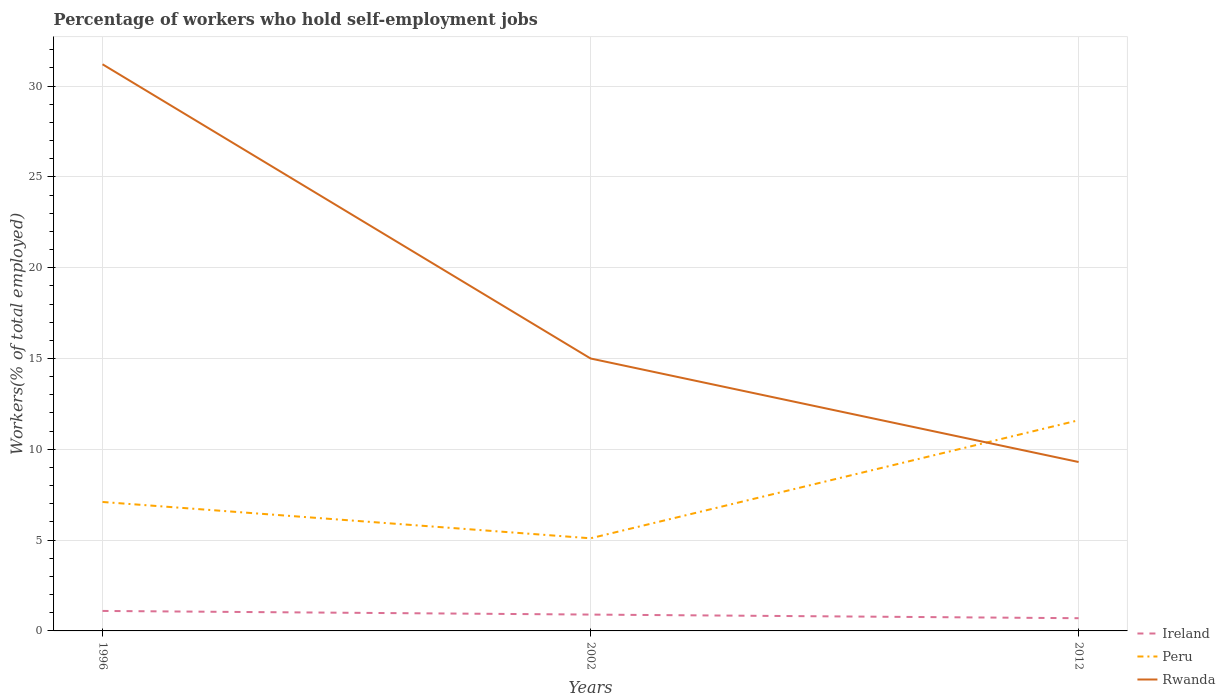Does the line corresponding to Ireland intersect with the line corresponding to Peru?
Give a very brief answer. No. Is the number of lines equal to the number of legend labels?
Keep it short and to the point. Yes. Across all years, what is the maximum percentage of self-employed workers in Rwanda?
Your answer should be very brief. 9.3. In which year was the percentage of self-employed workers in Ireland maximum?
Your answer should be very brief. 2012. What is the total percentage of self-employed workers in Ireland in the graph?
Your response must be concise. 0.4. What is the difference between the highest and the second highest percentage of self-employed workers in Peru?
Provide a short and direct response. 6.5. What is the difference between the highest and the lowest percentage of self-employed workers in Peru?
Keep it short and to the point. 1. Is the percentage of self-employed workers in Peru strictly greater than the percentage of self-employed workers in Rwanda over the years?
Ensure brevity in your answer.  No. How many lines are there?
Provide a short and direct response. 3. What is the difference between two consecutive major ticks on the Y-axis?
Offer a terse response. 5. Are the values on the major ticks of Y-axis written in scientific E-notation?
Your answer should be compact. No. Does the graph contain any zero values?
Ensure brevity in your answer.  No. Where does the legend appear in the graph?
Your answer should be very brief. Bottom right. How many legend labels are there?
Offer a very short reply. 3. What is the title of the graph?
Make the answer very short. Percentage of workers who hold self-employment jobs. What is the label or title of the X-axis?
Ensure brevity in your answer.  Years. What is the label or title of the Y-axis?
Provide a short and direct response. Workers(% of total employed). What is the Workers(% of total employed) in Ireland in 1996?
Provide a succinct answer. 1.1. What is the Workers(% of total employed) in Peru in 1996?
Offer a terse response. 7.1. What is the Workers(% of total employed) of Rwanda in 1996?
Provide a short and direct response. 31.2. What is the Workers(% of total employed) in Ireland in 2002?
Your answer should be very brief. 0.9. What is the Workers(% of total employed) of Peru in 2002?
Ensure brevity in your answer.  5.1. What is the Workers(% of total employed) in Rwanda in 2002?
Make the answer very short. 15. What is the Workers(% of total employed) in Ireland in 2012?
Your answer should be compact. 0.7. What is the Workers(% of total employed) of Peru in 2012?
Your response must be concise. 11.6. What is the Workers(% of total employed) of Rwanda in 2012?
Your response must be concise. 9.3. Across all years, what is the maximum Workers(% of total employed) in Ireland?
Keep it short and to the point. 1.1. Across all years, what is the maximum Workers(% of total employed) of Peru?
Provide a short and direct response. 11.6. Across all years, what is the maximum Workers(% of total employed) of Rwanda?
Ensure brevity in your answer.  31.2. Across all years, what is the minimum Workers(% of total employed) of Ireland?
Provide a short and direct response. 0.7. Across all years, what is the minimum Workers(% of total employed) of Peru?
Keep it short and to the point. 5.1. Across all years, what is the minimum Workers(% of total employed) in Rwanda?
Provide a succinct answer. 9.3. What is the total Workers(% of total employed) of Ireland in the graph?
Your response must be concise. 2.7. What is the total Workers(% of total employed) in Peru in the graph?
Make the answer very short. 23.8. What is the total Workers(% of total employed) of Rwanda in the graph?
Offer a very short reply. 55.5. What is the difference between the Workers(% of total employed) of Ireland in 1996 and that in 2002?
Offer a very short reply. 0.2. What is the difference between the Workers(% of total employed) in Rwanda in 1996 and that in 2002?
Offer a very short reply. 16.2. What is the difference between the Workers(% of total employed) in Ireland in 1996 and that in 2012?
Offer a very short reply. 0.4. What is the difference between the Workers(% of total employed) in Rwanda in 1996 and that in 2012?
Offer a very short reply. 21.9. What is the difference between the Workers(% of total employed) of Ireland in 1996 and the Workers(% of total employed) of Rwanda in 2002?
Keep it short and to the point. -13.9. What is the difference between the Workers(% of total employed) in Peru in 2002 and the Workers(% of total employed) in Rwanda in 2012?
Your answer should be very brief. -4.2. What is the average Workers(% of total employed) of Peru per year?
Ensure brevity in your answer.  7.93. What is the average Workers(% of total employed) in Rwanda per year?
Your answer should be compact. 18.5. In the year 1996, what is the difference between the Workers(% of total employed) of Ireland and Workers(% of total employed) of Rwanda?
Your answer should be compact. -30.1. In the year 1996, what is the difference between the Workers(% of total employed) of Peru and Workers(% of total employed) of Rwanda?
Provide a succinct answer. -24.1. In the year 2002, what is the difference between the Workers(% of total employed) of Ireland and Workers(% of total employed) of Peru?
Ensure brevity in your answer.  -4.2. In the year 2002, what is the difference between the Workers(% of total employed) of Ireland and Workers(% of total employed) of Rwanda?
Your answer should be very brief. -14.1. In the year 2002, what is the difference between the Workers(% of total employed) in Peru and Workers(% of total employed) in Rwanda?
Provide a short and direct response. -9.9. What is the ratio of the Workers(% of total employed) in Ireland in 1996 to that in 2002?
Provide a short and direct response. 1.22. What is the ratio of the Workers(% of total employed) in Peru in 1996 to that in 2002?
Keep it short and to the point. 1.39. What is the ratio of the Workers(% of total employed) in Rwanda in 1996 to that in 2002?
Provide a short and direct response. 2.08. What is the ratio of the Workers(% of total employed) of Ireland in 1996 to that in 2012?
Provide a succinct answer. 1.57. What is the ratio of the Workers(% of total employed) of Peru in 1996 to that in 2012?
Give a very brief answer. 0.61. What is the ratio of the Workers(% of total employed) of Rwanda in 1996 to that in 2012?
Ensure brevity in your answer.  3.35. What is the ratio of the Workers(% of total employed) of Peru in 2002 to that in 2012?
Your answer should be very brief. 0.44. What is the ratio of the Workers(% of total employed) of Rwanda in 2002 to that in 2012?
Your answer should be compact. 1.61. What is the difference between the highest and the lowest Workers(% of total employed) in Rwanda?
Keep it short and to the point. 21.9. 